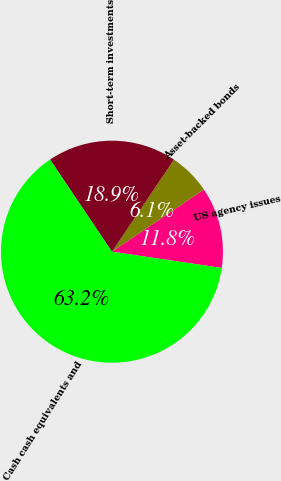<chart> <loc_0><loc_0><loc_500><loc_500><pie_chart><fcel>US agency issues<fcel>Asset-backed bonds<fcel>Short-term investments<fcel>Cash cash equivalents and<nl><fcel>11.81%<fcel>6.1%<fcel>18.85%<fcel>63.24%<nl></chart> 